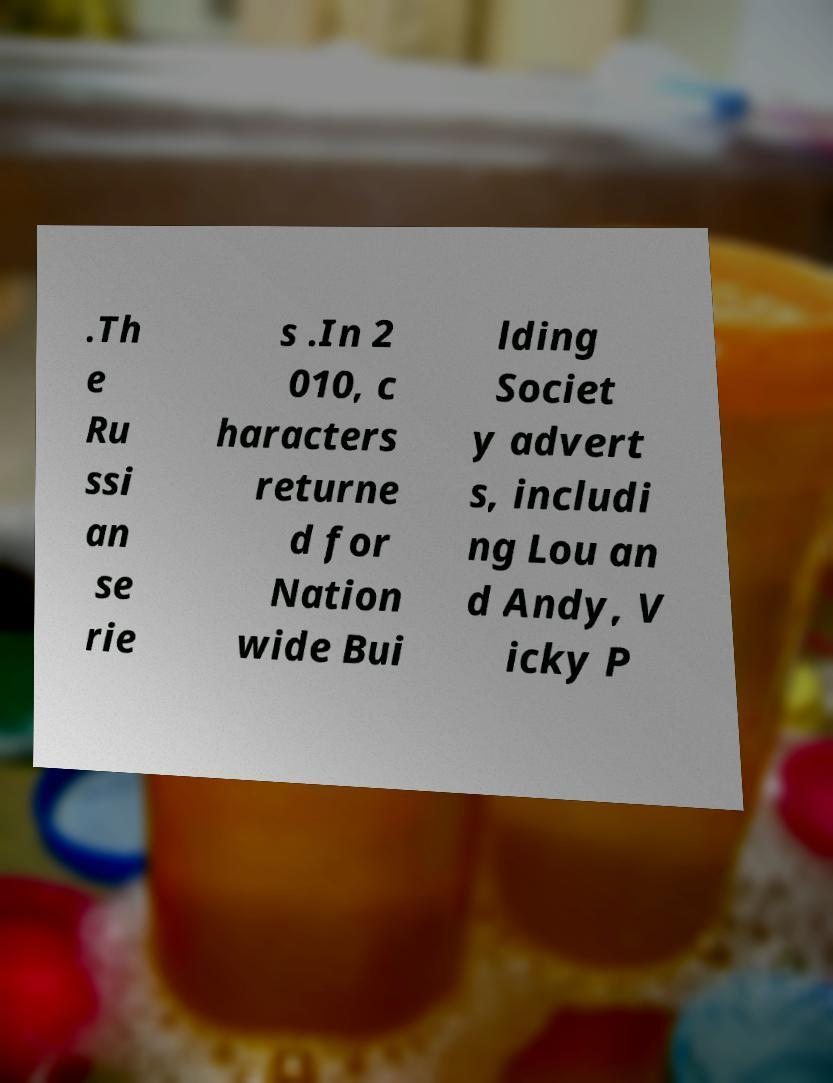Please read and relay the text visible in this image. What does it say? .Th e Ru ssi an se rie s .In 2 010, c haracters returne d for Nation wide Bui lding Societ y advert s, includi ng Lou an d Andy, V icky P 